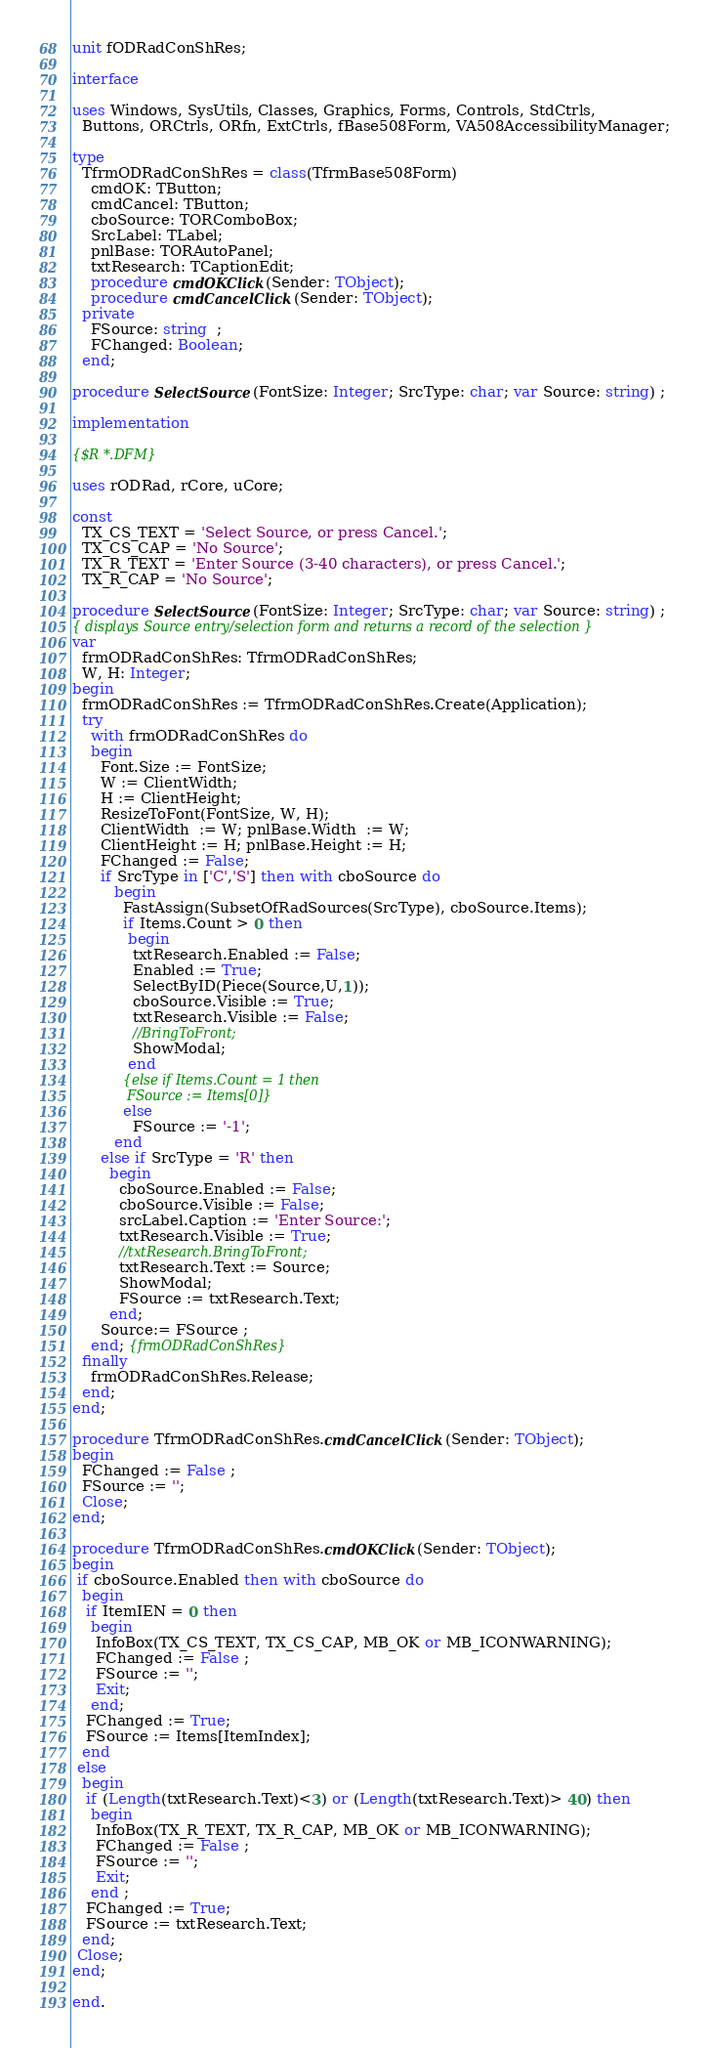<code> <loc_0><loc_0><loc_500><loc_500><_Pascal_>unit fODRadConShRes;

interface

uses Windows, SysUtils, Classes, Graphics, Forms, Controls, StdCtrls,
  Buttons, ORCtrls, ORfn, ExtCtrls, fBase508Form, VA508AccessibilityManager;

type
  TfrmODRadConShRes = class(TfrmBase508Form)
    cmdOK: TButton;
    cmdCancel: TButton;
    cboSource: TORComboBox;
    SrcLabel: TLabel;
    pnlBase: TORAutoPanel;
    txtResearch: TCaptionEdit;
    procedure cmdOKClick(Sender: TObject);
    procedure cmdCancelClick(Sender: TObject);
  private
    FSource: string  ;
    FChanged: Boolean;
  end;

procedure SelectSource(FontSize: Integer; SrcType: char; var Source: string) ;

implementation

{$R *.DFM}

uses rODRad, rCore, uCore;

const
  TX_CS_TEXT = 'Select Source, or press Cancel.';
  TX_CS_CAP = 'No Source';
  TX_R_TEXT = 'Enter Source (3-40 characters), or press Cancel.';
  TX_R_CAP = 'No Source';

procedure SelectSource(FontSize: Integer; SrcType: char; var Source: string) ;
{ displays Source entry/selection form and returns a record of the selection }
var
  frmODRadConShRes: TfrmODRadConShRes;
  W, H: Integer;
begin
  frmODRadConShRes := TfrmODRadConShRes.Create(Application);
  try
    with frmODRadConShRes do
    begin
      Font.Size := FontSize;
      W := ClientWidth;
      H := ClientHeight;
      ResizeToFont(FontSize, W, H);
      ClientWidth  := W; pnlBase.Width  := W;
      ClientHeight := H; pnlBase.Height := H;
      FChanged := False;
      if SrcType in ['C','S'] then with cboSource do
         begin
           FastAssign(SubsetOfRadSources(SrcType), cboSource.Items);
           if Items.Count > 0 then
            begin
             txtResearch.Enabled := False;
             Enabled := True;
             SelectByID(Piece(Source,U,1));
             cboSource.Visible := True;
             txtResearch.Visible := False;
             //BringToFront;
             ShowModal;
            end
           {else if Items.Count = 1 then
             FSource := Items[0]}
           else
             FSource := '-1';
         end
      else if SrcType = 'R' then
        begin
          cboSource.Enabled := False;
          cboSource.Visible := False;
          srcLabel.Caption := 'Enter Source:';
          txtResearch.Visible := True;
          //txtResearch.BringToFront;
          txtResearch.Text := Source;
          ShowModal;
          FSource := txtResearch.Text;
        end;
      Source:= FSource ;
    end; {frmODRadConShRes}
  finally
    frmODRadConShRes.Release;
  end;
end;

procedure TfrmODRadConShRes.cmdCancelClick(Sender: TObject);
begin
  FChanged := False ;
  FSource := '';
  Close;
end;

procedure TfrmODRadConShRes.cmdOKClick(Sender: TObject);
begin
 if cboSource.Enabled then with cboSource do
  begin
   if ItemIEN = 0 then
    begin
     InfoBox(TX_CS_TEXT, TX_CS_CAP, MB_OK or MB_ICONWARNING);
     FChanged := False ;
     FSource := '';
     Exit;
    end;
   FChanged := True;
   FSource := Items[ItemIndex];
  end
 else
  begin
   if (Length(txtResearch.Text)<3) or (Length(txtResearch.Text)> 40) then
    begin
     InfoBox(TX_R_TEXT, TX_R_CAP, MB_OK or MB_ICONWARNING);
     FChanged := False ;
     FSource := '';
     Exit;
    end ;
   FChanged := True;
   FSource := txtResearch.Text;
  end;
 Close;
end;

end.
</code> 